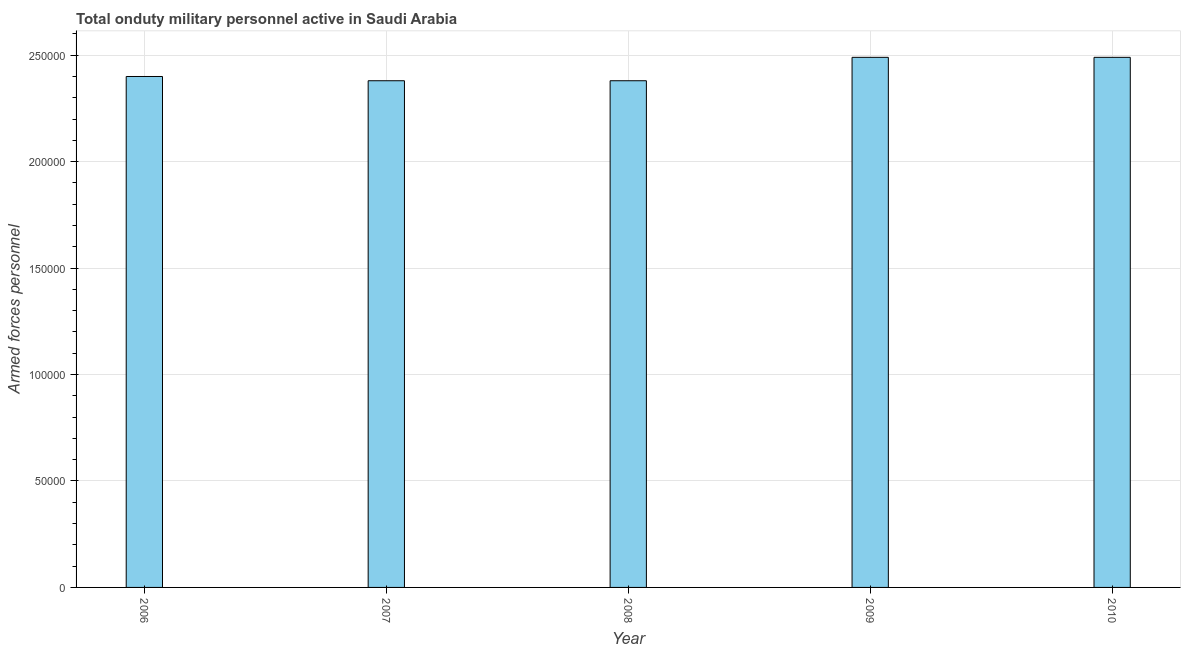What is the title of the graph?
Make the answer very short. Total onduty military personnel active in Saudi Arabia. What is the label or title of the Y-axis?
Ensure brevity in your answer.  Armed forces personnel. What is the number of armed forces personnel in 2009?
Ensure brevity in your answer.  2.49e+05. Across all years, what is the maximum number of armed forces personnel?
Offer a terse response. 2.49e+05. Across all years, what is the minimum number of armed forces personnel?
Make the answer very short. 2.38e+05. In which year was the number of armed forces personnel minimum?
Give a very brief answer. 2007. What is the sum of the number of armed forces personnel?
Ensure brevity in your answer.  1.21e+06. What is the difference between the number of armed forces personnel in 2007 and 2009?
Ensure brevity in your answer.  -1.10e+04. What is the average number of armed forces personnel per year?
Offer a very short reply. 2.43e+05. What is the median number of armed forces personnel?
Make the answer very short. 2.40e+05. In how many years, is the number of armed forces personnel greater than 210000 ?
Your answer should be very brief. 5. Do a majority of the years between 2006 and 2007 (inclusive) have number of armed forces personnel greater than 20000 ?
Offer a very short reply. Yes. Is the number of armed forces personnel in 2006 less than that in 2007?
Your answer should be very brief. No. Is the difference between the number of armed forces personnel in 2006 and 2010 greater than the difference between any two years?
Make the answer very short. No. What is the difference between the highest and the lowest number of armed forces personnel?
Make the answer very short. 1.10e+04. In how many years, is the number of armed forces personnel greater than the average number of armed forces personnel taken over all years?
Provide a succinct answer. 2. Are all the bars in the graph horizontal?
Your response must be concise. No. How many years are there in the graph?
Provide a short and direct response. 5. What is the Armed forces personnel in 2007?
Provide a succinct answer. 2.38e+05. What is the Armed forces personnel of 2008?
Your response must be concise. 2.38e+05. What is the Armed forces personnel in 2009?
Your answer should be very brief. 2.49e+05. What is the Armed forces personnel of 2010?
Ensure brevity in your answer.  2.49e+05. What is the difference between the Armed forces personnel in 2006 and 2007?
Offer a terse response. 2000. What is the difference between the Armed forces personnel in 2006 and 2008?
Your answer should be very brief. 2000. What is the difference between the Armed forces personnel in 2006 and 2009?
Provide a short and direct response. -9000. What is the difference between the Armed forces personnel in 2006 and 2010?
Offer a terse response. -9000. What is the difference between the Armed forces personnel in 2007 and 2008?
Your answer should be very brief. 0. What is the difference between the Armed forces personnel in 2007 and 2009?
Your answer should be compact. -1.10e+04. What is the difference between the Armed forces personnel in 2007 and 2010?
Ensure brevity in your answer.  -1.10e+04. What is the difference between the Armed forces personnel in 2008 and 2009?
Your answer should be very brief. -1.10e+04. What is the difference between the Armed forces personnel in 2008 and 2010?
Your answer should be compact. -1.10e+04. What is the difference between the Armed forces personnel in 2009 and 2010?
Keep it short and to the point. 0. What is the ratio of the Armed forces personnel in 2006 to that in 2009?
Give a very brief answer. 0.96. What is the ratio of the Armed forces personnel in 2006 to that in 2010?
Your response must be concise. 0.96. What is the ratio of the Armed forces personnel in 2007 to that in 2008?
Your answer should be compact. 1. What is the ratio of the Armed forces personnel in 2007 to that in 2009?
Provide a short and direct response. 0.96. What is the ratio of the Armed forces personnel in 2007 to that in 2010?
Provide a short and direct response. 0.96. What is the ratio of the Armed forces personnel in 2008 to that in 2009?
Your response must be concise. 0.96. What is the ratio of the Armed forces personnel in 2008 to that in 2010?
Offer a very short reply. 0.96. 